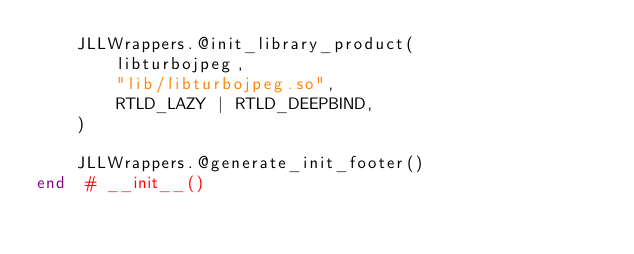<code> <loc_0><loc_0><loc_500><loc_500><_Julia_>    JLLWrappers.@init_library_product(
        libturbojpeg,
        "lib/libturbojpeg.so",
        RTLD_LAZY | RTLD_DEEPBIND,
    )

    JLLWrappers.@generate_init_footer()
end  # __init__()
</code> 